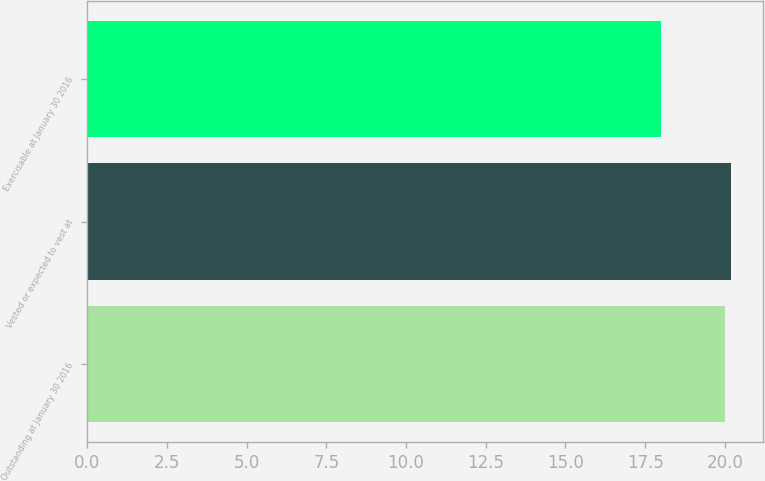<chart> <loc_0><loc_0><loc_500><loc_500><bar_chart><fcel>Outstanding at January 30 2016<fcel>Vested or expected to vest at<fcel>Exercisable at January 30 2016<nl><fcel>20<fcel>20.2<fcel>18<nl></chart> 